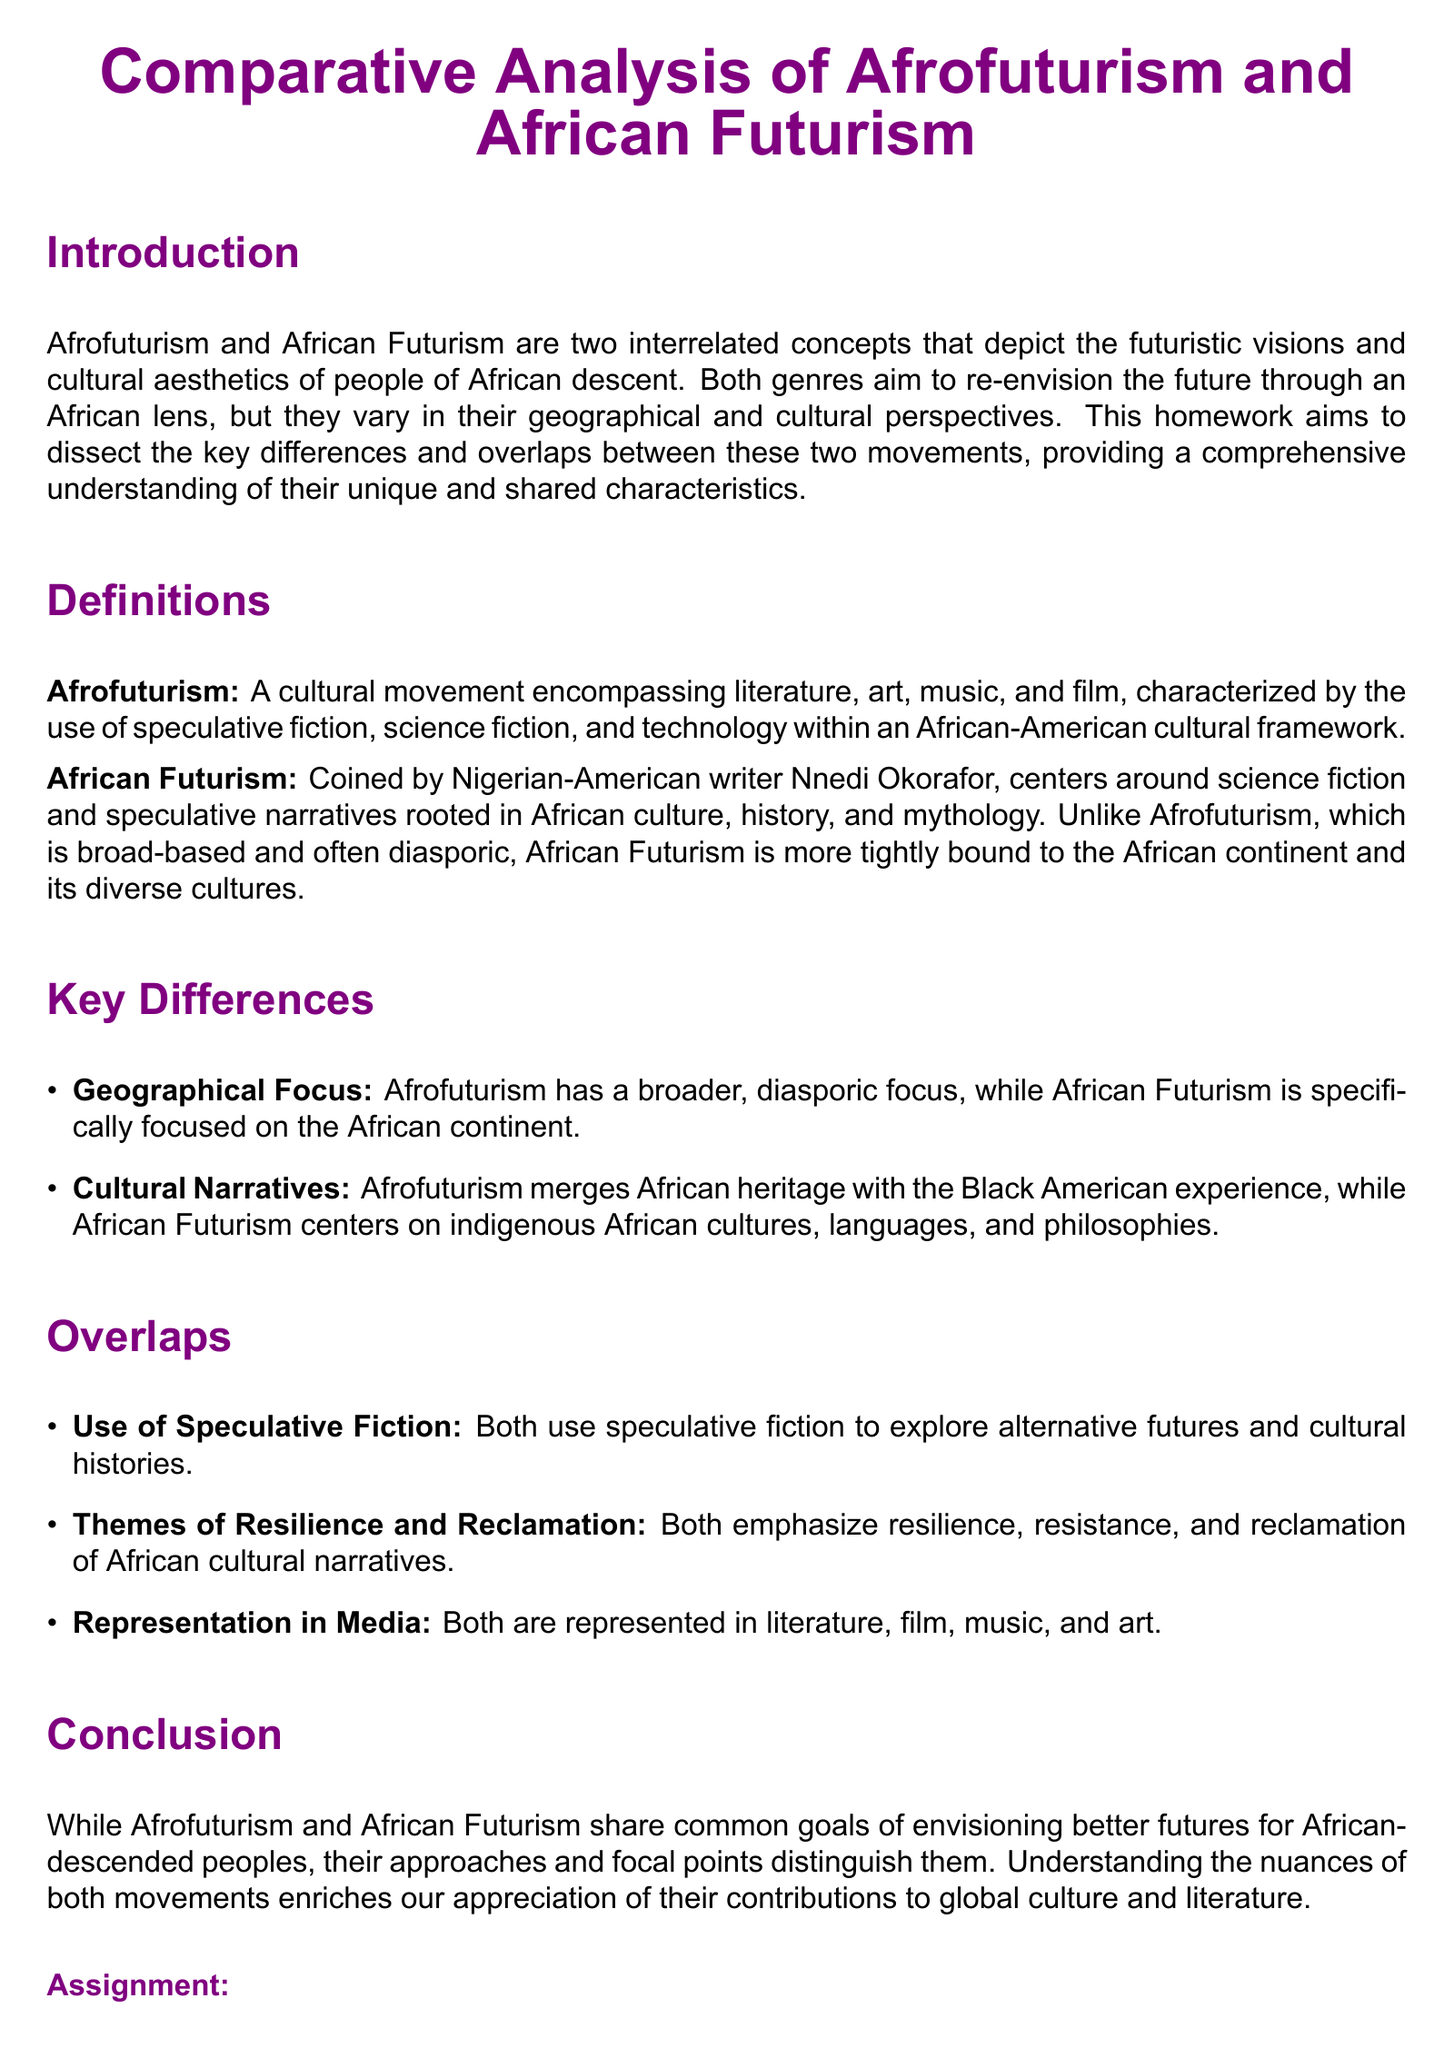What is the main focus of Afrofuturism? The main focus of Afrofuturism is the use of speculative fiction, science fiction, and technology within an African-American cultural framework.
Answer: Speculative fiction What is the term coined by Nnedi Okorafor? The term coined by Nnedi Okorafor is African Futurism, which focuses on narratives rooted in African culture.
Answer: African Futurism What is emphasized by both Afrofuturism and African Futurism? Both movements emphasize resilience, resistance, and reclamation of African cultural narratives.
Answer: Resilience What are the geographical focuses of Afrofuturism and African Futurism? Afrofuturism has a broader, diasporic focus, whereas African Futurism is specifically focused on the African continent.
Answer: Broader; specifically focused How many assignment tasks are listed in the document? The number of assignment tasks listed in the document is three.
Answer: Three What type of essay is required in the assignment? The assignment requires a 500-word essay comparing and contrasting Afrofuturism and African Futurism.
Answer: 500-word essay What is the color used for the title text in the document? The color used for the title text in the document is afropurple.
Answer: Afropurple In which areas are both movements represented? Both movements are represented in literature, film, music, and art.
Answer: Literature, film, music, art What is the due date for the assignment? The due date is specified as two weeks from today.
Answer: Two weeks from today 